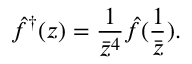Convert formula to latex. <formula><loc_0><loc_0><loc_500><loc_500>\hat { f } ^ { \dagger } ( z ) = { \frac { 1 } { \bar { z } ^ { 4 } } } { \hat { f } ( { \frac { 1 } { \bar { z } } } ) } .</formula> 